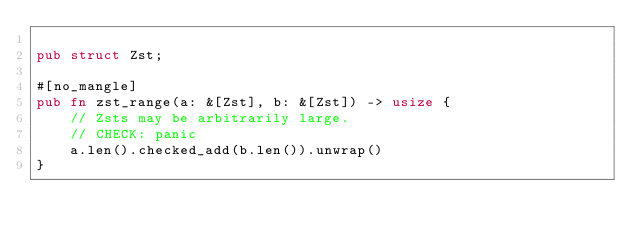<code> <loc_0><loc_0><loc_500><loc_500><_Rust_>
pub struct Zst;

#[no_mangle]
pub fn zst_range(a: &[Zst], b: &[Zst]) -> usize {
    // Zsts may be arbitrarily large.
    // CHECK: panic
    a.len().checked_add(b.len()).unwrap()
}
</code> 